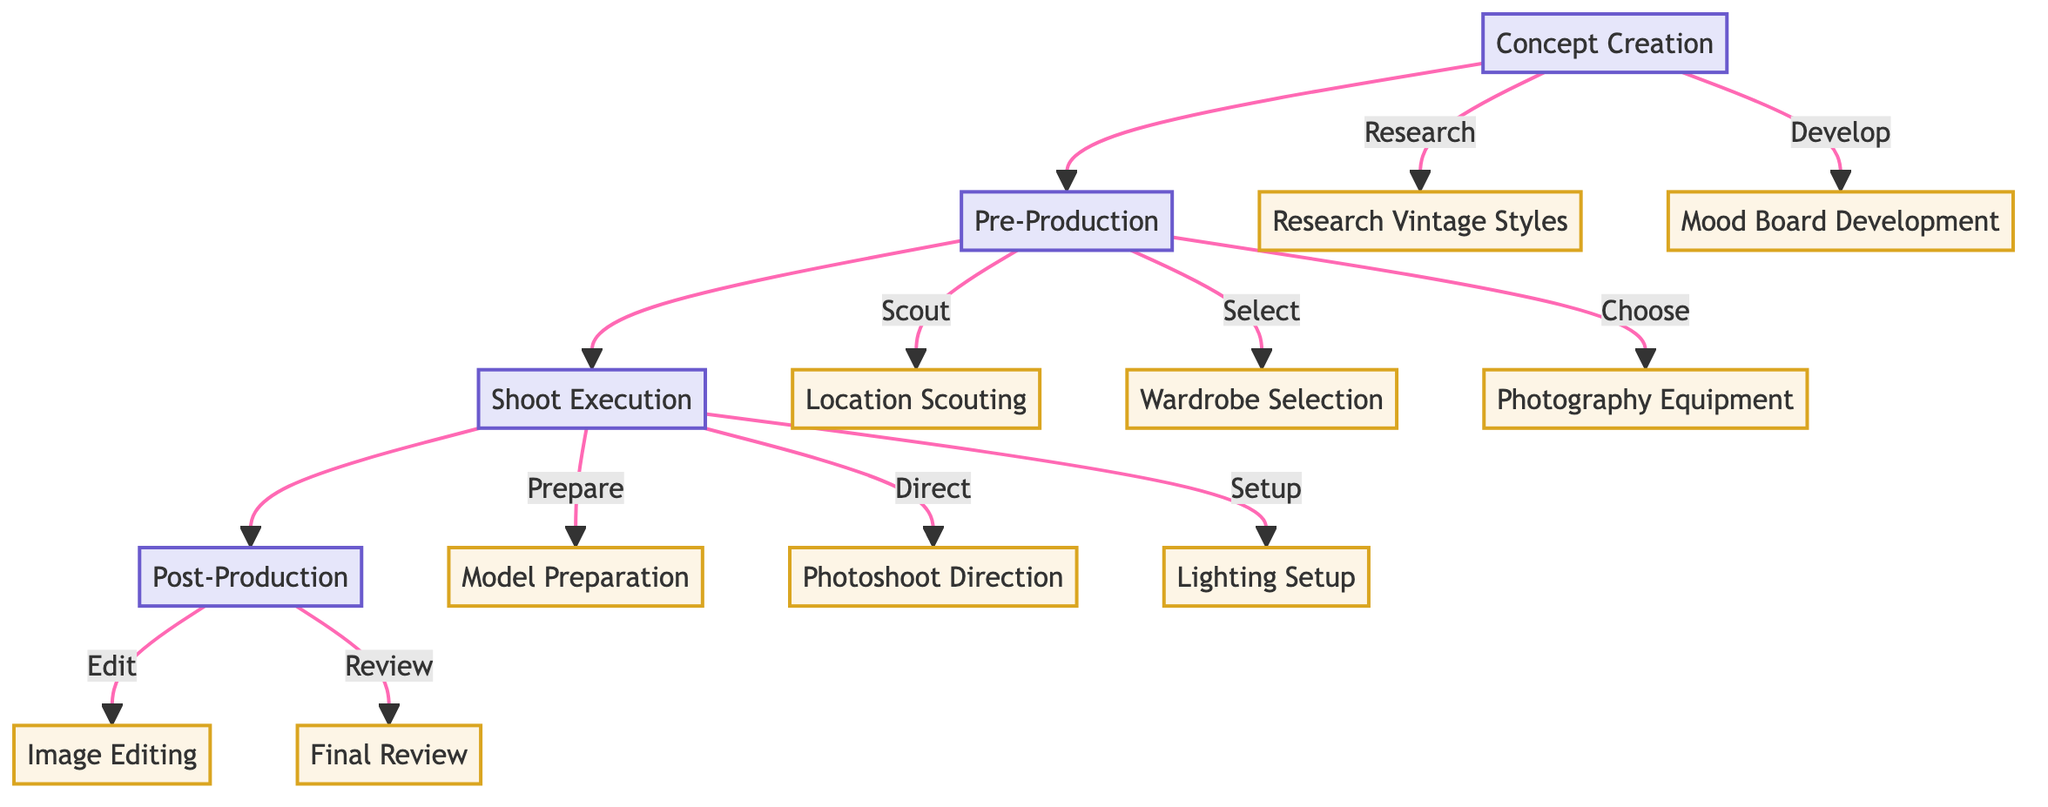What is the first phase of the workflow? The diagram indicates that the first phase is "Concept Creation." This is represented as the topmost node, and it leads to the next phase, "Pre-Production."
Answer: Concept Creation How many main phases are in the workflow? The flowchart outlines four main phases: "Concept Creation," "Pre-Production," "Shoot Execution," and "Post-Production." Each is clearly separated and connected sequentially.
Answer: 4 What task is associated with the "Concept Creation" phase? Under the "Concept Creation" phase, two tasks are listed: "Research Vintage Styles" and "Mood Board Development." These tasks indicate the activities performed during this phase.
Answer: Research Vintage Styles, Mood Board Development Which phase involves selecting locations? The task "Location Scouting" is part of the "Pre-Production" phase, indicating that it involves selecting appropriate locations for the photoshoot. This is the only task that pertains to location selection.
Answer: Pre-Production How does "Model Preparation" relate to "Shoot Execution"? "Model Preparation" is a task that falls under the "Shoot Execution" phase. It specifically relates to preparing the model with vintage outfits in a way that aligns with the overall theme of vintage fashion.
Answer: Shoot Execution What is the last task in the workflow? The last task within the workflow is "Final Review," which occurs during the "Post-Production" phase. It concludes the process by choosing the final images for publication or portfolio.
Answer: Final Review Which phase includes photo editing techniques? The "Image Editing" task is contained within the "Post-Production" phase, indicating that it focuses on applying filters and effects to achieve a vintage style.
Answer: Post-Production What is the overall purpose of the workflow? The purpose of the workflow is to provide a structured process from concept creation through to shoot execution and post-production, specifically emphasizing the vintage fashion theme throughout.
Answer: Structured process What type of lighting is suggested for the "Lighting Setup"? The diagram specifies "soft lighting" for the "Lighting Setup" during the "Shoot Execution" phase, indicating the intention to enhance the retro vibe associated with vintage fashion.
Answer: Soft lighting 